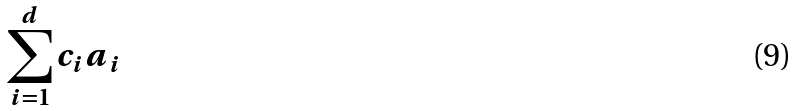Convert formula to latex. <formula><loc_0><loc_0><loc_500><loc_500>\sum _ { i = 1 } ^ { d } c _ { i } a _ { i }</formula> 